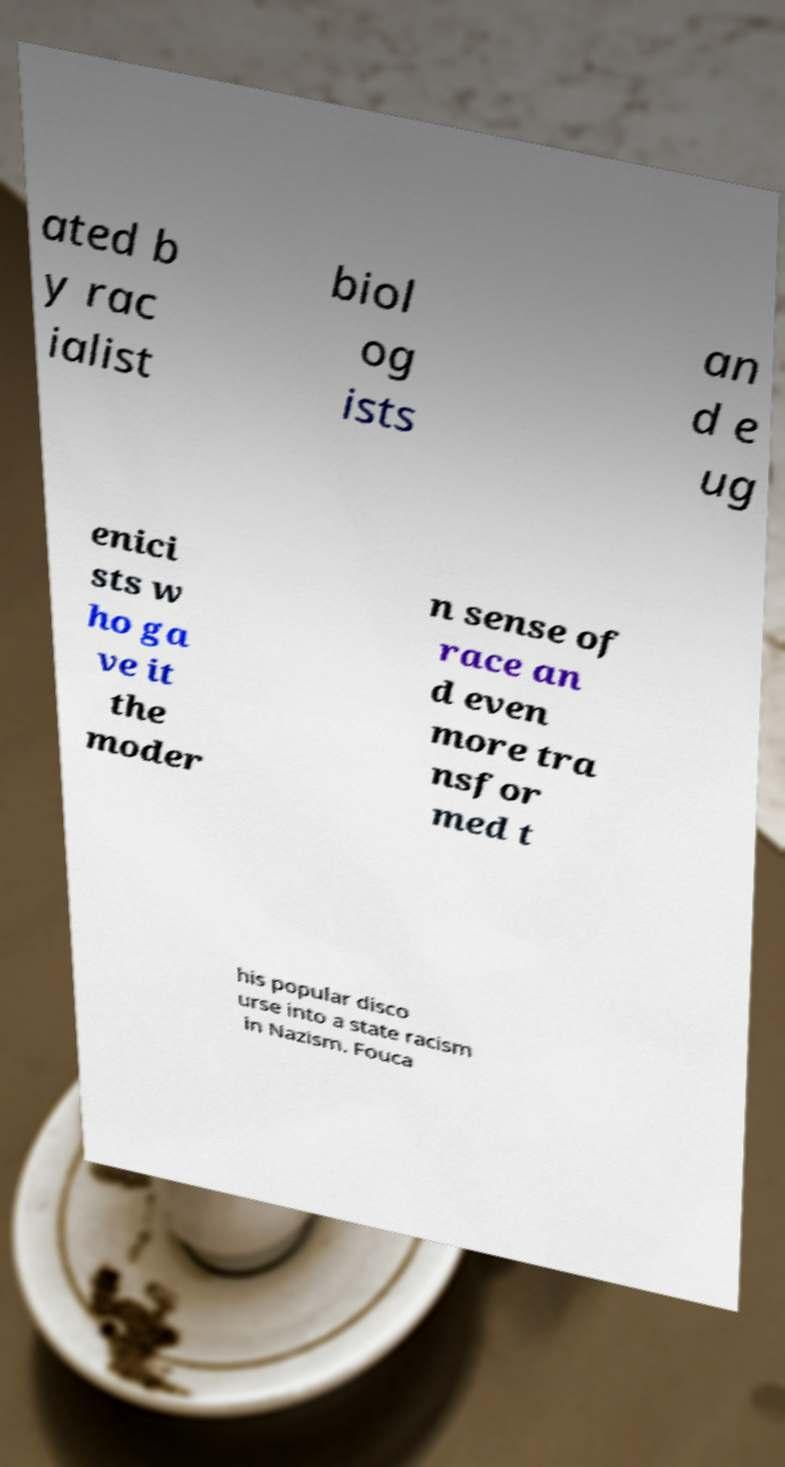Can you accurately transcribe the text from the provided image for me? ated b y rac ialist biol og ists an d e ug enici sts w ho ga ve it the moder n sense of race an d even more tra nsfor med t his popular disco urse into a state racism in Nazism. Fouca 